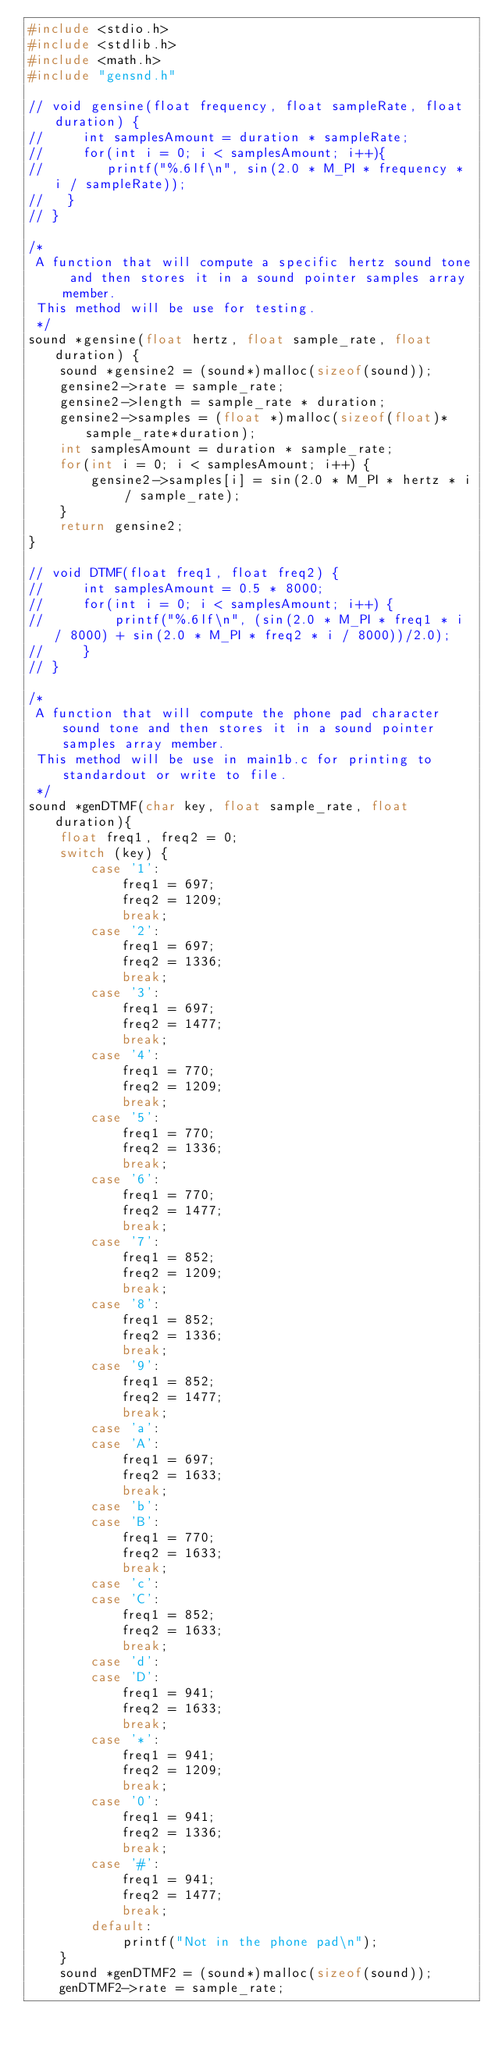<code> <loc_0><loc_0><loc_500><loc_500><_C_>#include <stdio.h>
#include <stdlib.h>
#include <math.h>
#include "gensnd.h"

// void gensine(float frequency, float sampleRate, float duration) {
//     int samplesAmount = duration * sampleRate;
//     for(int i = 0; i < samplesAmount; i++){
//        printf("%.6lf\n", sin(2.0 * M_PI * frequency * i / sampleRate));
//   }
// }

/*
 A function that will compute a specific hertz sound tone and then stores it in a sound pointer samples array member.
 This method will be use for testing.
 */
sound *gensine(float hertz, float sample_rate, float duration) {
    sound *gensine2 = (sound*)malloc(sizeof(sound));
    gensine2->rate = sample_rate;
    gensine2->length = sample_rate * duration;
    gensine2->samples = (float *)malloc(sizeof(float)*sample_rate*duration);
    int samplesAmount = duration * sample_rate;
    for(int i = 0; i < samplesAmount; i++) {
        gensine2->samples[i] = sin(2.0 * M_PI * hertz * i / sample_rate);
    }
    return gensine2;
}

// void DTMF(float freq1, float freq2) {
//     int samplesAmount = 0.5 * 8000;
//     for(int i = 0; i < samplesAmount; i++) {
//         printf("%.6lf\n", (sin(2.0 * M_PI * freq1 * i / 8000) + sin(2.0 * M_PI * freq2 * i / 8000))/2.0);
//     }
// }

/*
 A function that will compute the phone pad character sound tone and then stores it in a sound pointer samples array member.
 This method will be use in main1b.c for printing to standardout or write to file.
 */
sound *genDTMF(char key, float sample_rate, float duration){
    float freq1, freq2 = 0;
    switch (key) {
        case '1':
            freq1 = 697;
            freq2 = 1209;
            break;
        case '2':
            freq1 = 697;
            freq2 = 1336;
            break;
        case '3':
            freq1 = 697;
            freq2 = 1477;
            break;
        case '4':
            freq1 = 770;
            freq2 = 1209;
            break;
        case '5':
            freq1 = 770;
            freq2 = 1336;
            break;
        case '6':
            freq1 = 770;
            freq2 = 1477;
            break;
        case '7':
            freq1 = 852;
            freq2 = 1209;
            break;
        case '8':
            freq1 = 852;
            freq2 = 1336;
            break;
        case '9':
            freq1 = 852;
            freq2 = 1477;
            break;
        case 'a':
        case 'A':
            freq1 = 697;
            freq2 = 1633;
            break;
        case 'b':
        case 'B':
            freq1 = 770;
            freq2 = 1633;
            break;
        case 'c':
        case 'C':
            freq1 = 852;
            freq2 = 1633;
            break;
        case 'd':
        case 'D':
            freq1 = 941;
            freq2 = 1633;
            break;
        case '*':
            freq1 = 941;
            freq2 = 1209;
            break;
        case '0':
            freq1 = 941;
            freq2 = 1336;
            break;
        case '#':
            freq1 = 941;
            freq2 = 1477;
            break;
        default:
            printf("Not in the phone pad\n");
    }
    sound *genDTMF2 = (sound*)malloc(sizeof(sound));
    genDTMF2->rate = sample_rate;</code> 